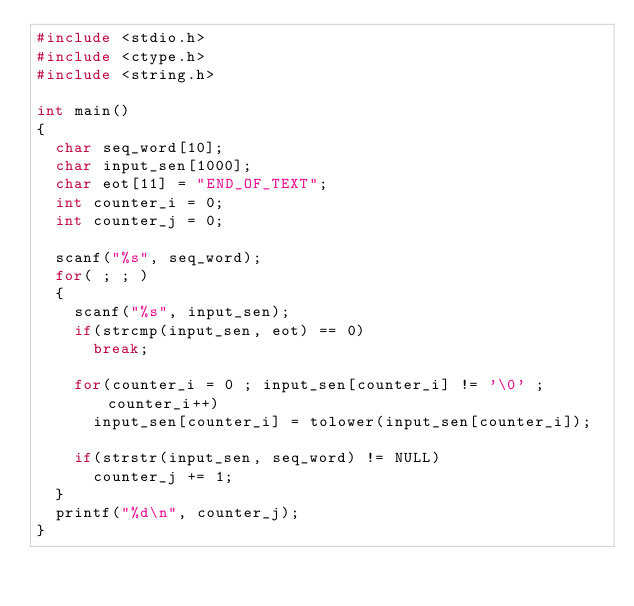Convert code to text. <code><loc_0><loc_0><loc_500><loc_500><_C_>#include <stdio.h>
#include <ctype.h>
#include <string.h>

int main()
{
  char seq_word[10];
  char input_sen[1000];
  char eot[11] = "END_OF_TEXT";
  int counter_i = 0;
  int counter_j = 0;

  scanf("%s", seq_word);
  for( ; ; )
  {
    scanf("%s", input_sen);
    if(strcmp(input_sen, eot) == 0)
      break;

    for(counter_i = 0 ; input_sen[counter_i] != '\0' ; counter_i++)
      input_sen[counter_i] = tolower(input_sen[counter_i]);

    if(strstr(input_sen, seq_word) != NULL)
      counter_j += 1;
  }
  printf("%d\n", counter_j);
}

</code> 